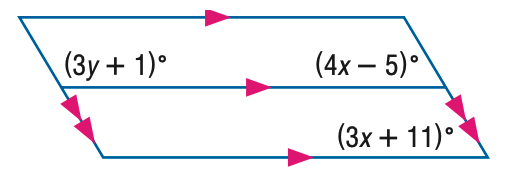Answer the mathemtical geometry problem and directly provide the correct option letter.
Question: Find y in the figure.
Choices: A: 30 B: 35 C: 40 D: 45 C 